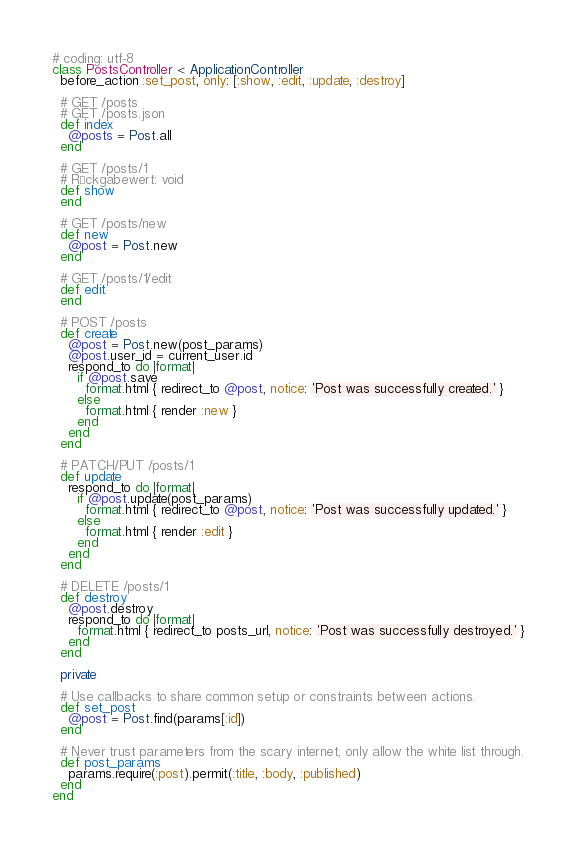Convert code to text. <code><loc_0><loc_0><loc_500><loc_500><_Ruby_># coding: utf-8
class PostsController < ApplicationController
  before_action :set_post, only: [:show, :edit, :update, :destroy]

  # GET /posts
  # GET /posts.json
  def index
    @posts = Post.all
  end

  # GET /posts/1
  # Rückgabewert: void
  def show
  end

  # GET /posts/new
  def new
    @post = Post.new
  end

  # GET /posts/1/edit
  def edit
  end

  # POST /posts
  def create
    @post = Post.new(post_params)
    @post.user_id = current_user.id
    respond_to do |format|
      if @post.save
        format.html { redirect_to @post, notice: 'Post was successfully created.' }
      else
        format.html { render :new }
      end
    end
  end

  # PATCH/PUT /posts/1
  def update
    respond_to do |format|
      if @post.update(post_params)
        format.html { redirect_to @post, notice: 'Post was successfully updated.' }
      else
        format.html { render :edit }
      end
    end
  end

  # DELETE /posts/1
  def destroy
    @post.destroy
    respond_to do |format|
      format.html { redirect_to posts_url, notice: 'Post was successfully destroyed.' }
    end
  end

  private

  # Use callbacks to share common setup or constraints between actions.
  def set_post
    @post = Post.find(params[:id])
  end

  # Never trust parameters from the scary internet, only allow the white list through.
  def post_params
    params.require(:post).permit(:title, :body, :published)
  end
end
</code> 